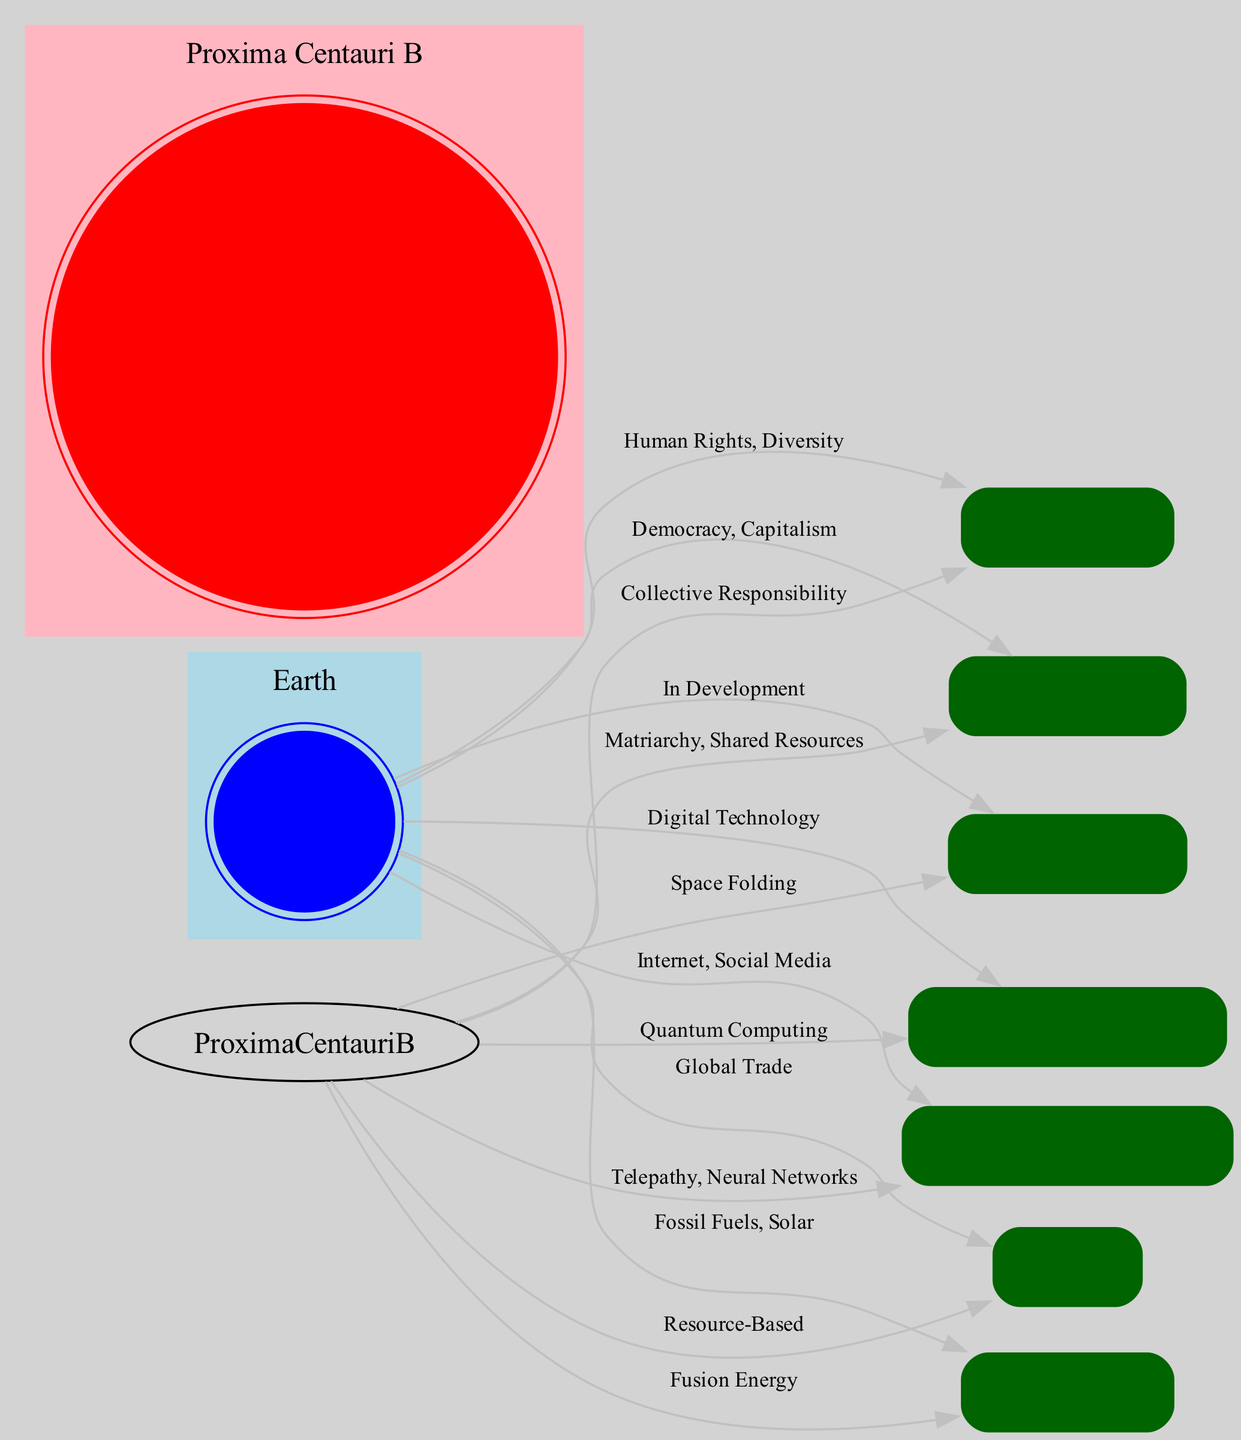What cultural norm is associated with Earth? The diagram shows an edge connecting Earth to the Cultural Norms node, with the label "Human Rights, Diversity." This indicates that these are the cultural norms that define Earth.
Answer: Human Rights, Diversity What is the primary energy source for Proxima Centauri B? The diagram includes a connection from Proxima Centauri B to the Energy Sources node, labeled "Fusion Energy." Thus, this is identified as the main energy source for Proxima Centauri B.
Answer: Fusion Energy How many nodes are present in the diagram? The diagram lists 8 distinct nodes, including Earth, Proxima Centauri B, and various comparison categories. Counting each gives a total of 8 nodes.
Answer: 8 Which civilization emphasizes collective responsibility in its cultural norms? The edge from Proxima Centauri B to Cultural Norms, labeled "Collective Responsibility," identifies this as a unique aspect of Proxima Centauri B's cultural norms.
Answer: Proxima Centauri B What is the relationship between technological advances and Earth? The diagram connects Earth to the Technological Advances node with the label "Digital Technology," indicating Earth’s technological advancements focus on digital technology.
Answer: Digital Technology Which communication method does Proxima Centauri B use? The edge from Proxima Centauri B to Communication Methods, labeled "Telepathy, Neural Networks," specifies this as the communication method for Proxima Centauri B.
Answer: Telepathy, Neural Networks How does Earth’s societal structure differ from Proxima Centauri B’s? Earth is connected to Societal Structure with "Democracy, Capitalism" while Proxima Centauri B is linked with "Matriarchy, Shared Resources." Comparing these labels shows the differences in societal structures.
Answer: Democracy, Capitalism; Matriarchy, Shared Resources What is the status of interstellar travel on Earth? The edge leading from Earth to Interstellar Travel, labeled "In Development," reveals that Earth’s interstellar travel is still being developed.
Answer: In Development What is the economic structure of Proxima Centauri B? The diagram shows Proxima Centauri B is connected to Economy with the label "Resource-Based," indicating this is its economic structure, in contrast to Earth's.
Answer: Resource-Based 